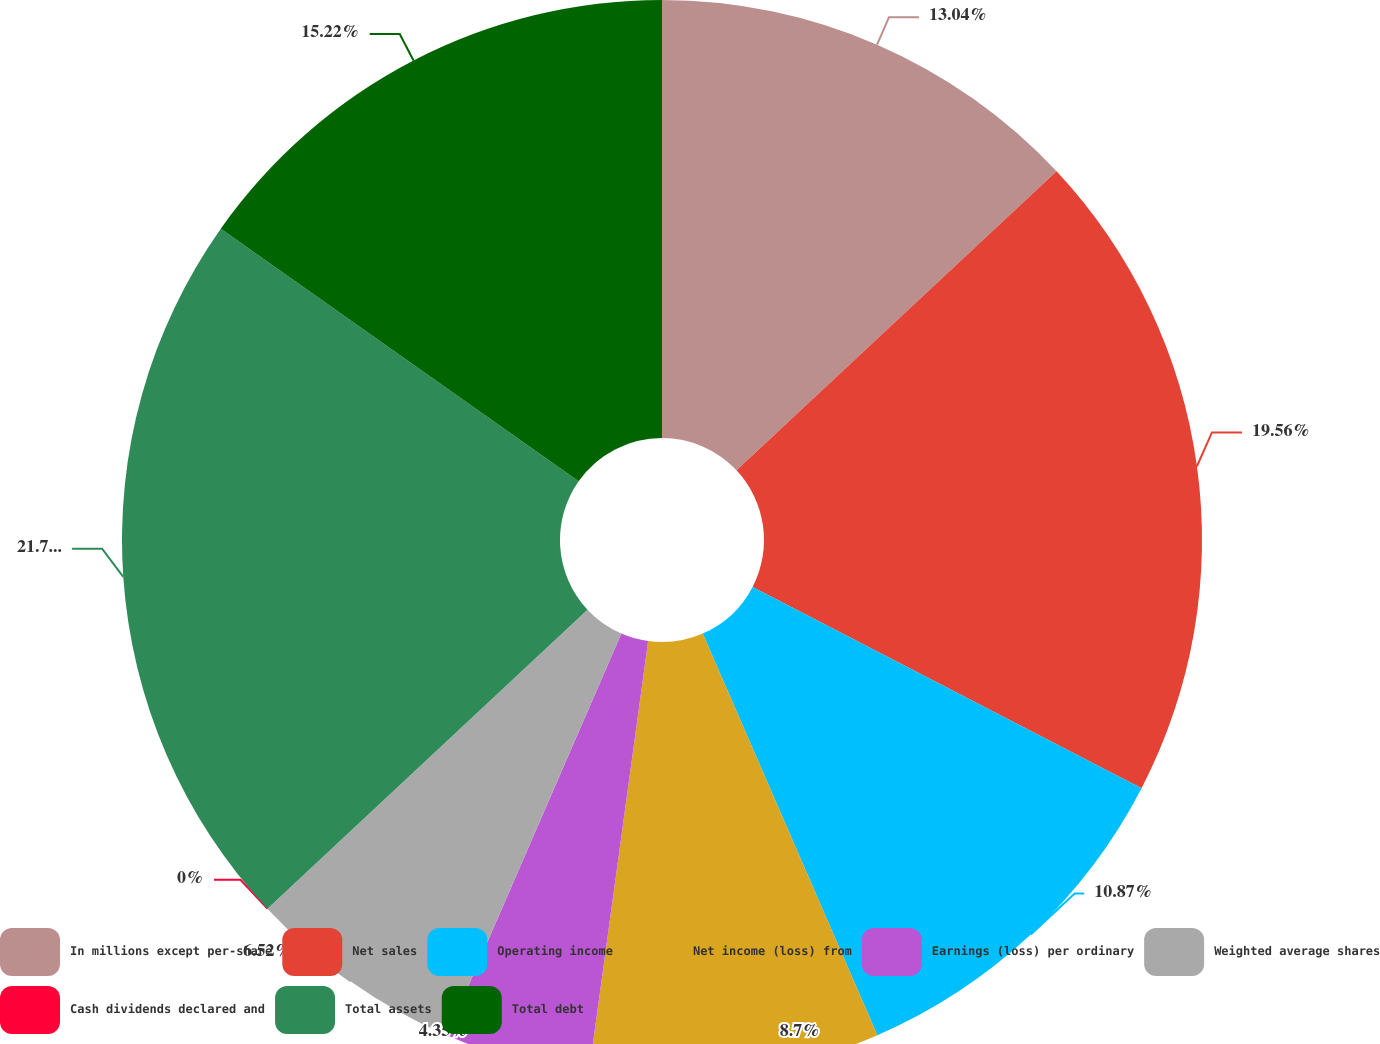Convert chart. <chart><loc_0><loc_0><loc_500><loc_500><pie_chart><fcel>In millions except per-share<fcel>Net sales<fcel>Operating income<fcel>Net income (loss) from<fcel>Earnings (loss) per ordinary<fcel>Weighted average shares<fcel>Cash dividends declared and<fcel>Total assets<fcel>Total debt<nl><fcel>13.04%<fcel>19.56%<fcel>10.87%<fcel>8.7%<fcel>4.35%<fcel>6.52%<fcel>0.0%<fcel>21.74%<fcel>15.22%<nl></chart> 